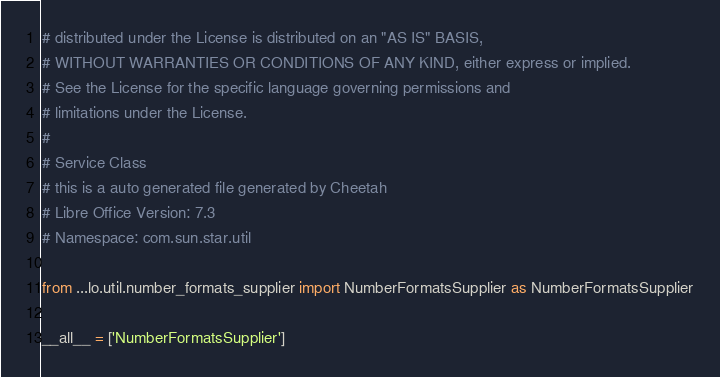<code> <loc_0><loc_0><loc_500><loc_500><_Python_># distributed under the License is distributed on an "AS IS" BASIS,
# WITHOUT WARRANTIES OR CONDITIONS OF ANY KIND, either express or implied.
# See the License for the specific language governing permissions and
# limitations under the License.
#
# Service Class
# this is a auto generated file generated by Cheetah
# Libre Office Version: 7.3
# Namespace: com.sun.star.util

from ...lo.util.number_formats_supplier import NumberFormatsSupplier as NumberFormatsSupplier

__all__ = ['NumberFormatsSupplier']

</code> 